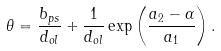Convert formula to latex. <formula><loc_0><loc_0><loc_500><loc_500>\theta = \frac { b _ { p s } } { d _ { o l } } + \frac { 1 } { d _ { o l } } \exp \left ( \frac { a _ { 2 } - \alpha } { a _ { 1 } } \right ) .</formula> 